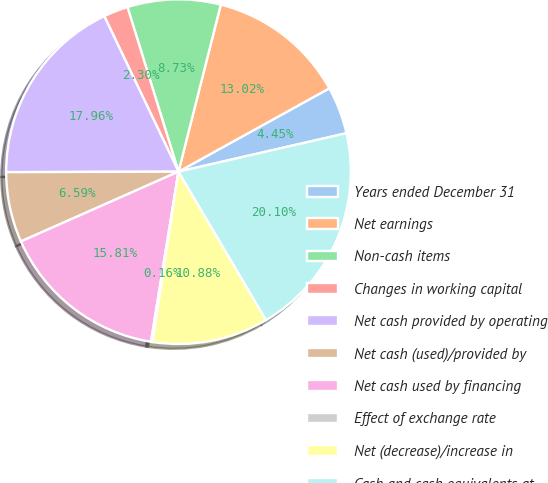<chart> <loc_0><loc_0><loc_500><loc_500><pie_chart><fcel>Years ended December 31<fcel>Net earnings<fcel>Non-cash items<fcel>Changes in working capital<fcel>Net cash provided by operating<fcel>Net cash (used)/provided by<fcel>Net cash used by financing<fcel>Effect of exchange rate<fcel>Net (decrease)/increase in<fcel>Cash and cash equivalents at<nl><fcel>4.45%<fcel>13.02%<fcel>8.73%<fcel>2.3%<fcel>17.96%<fcel>6.59%<fcel>15.81%<fcel>0.16%<fcel>10.88%<fcel>20.1%<nl></chart> 